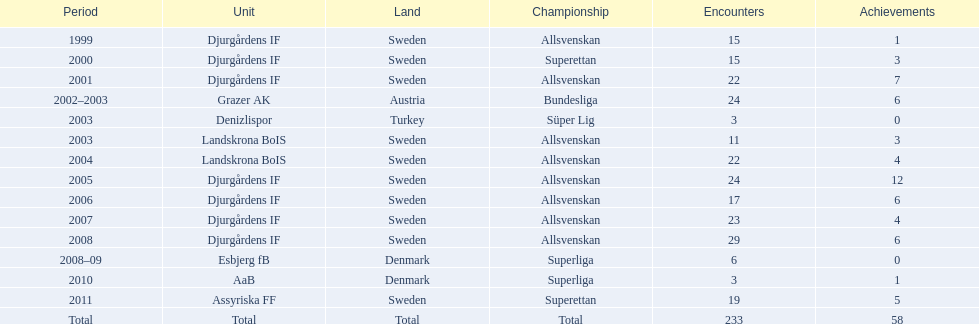What country is team djurgårdens if not from? Sweden. 